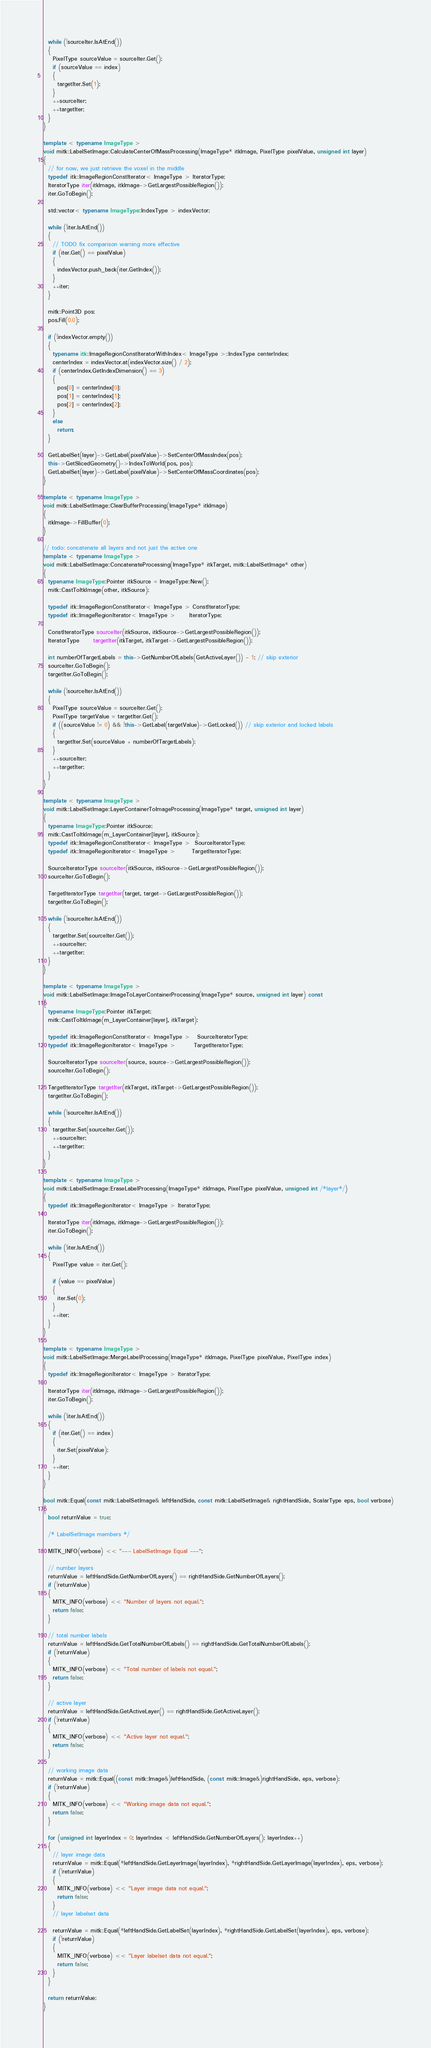<code> <loc_0><loc_0><loc_500><loc_500><_C++_>  while (!sourceIter.IsAtEnd())
  {
    PixelType sourceValue = sourceIter.Get();
    if (sourceValue == index)
    {
      targetIter.Set(1);
    }
    ++sourceIter;
    ++targetIter;
  }
}

template < typename ImageType >
void mitk::LabelSetImage::CalculateCenterOfMassProcessing(ImageType* itkImage, PixelType pixelValue, unsigned int layer)
{
  // for now, we just retrieve the voxel in the middle
  typedef itk::ImageRegionConstIterator< ImageType > IteratorType;
  IteratorType iter(itkImage, itkImage->GetLargestPossibleRegion());
  iter.GoToBegin();

  std::vector< typename ImageType::IndexType > indexVector;

  while (!iter.IsAtEnd())
  {
    // TODO fix comparison warning more effective
    if (iter.Get() == pixelValue)
    {
      indexVector.push_back(iter.GetIndex());
    }
    ++iter;
  }

  mitk::Point3D pos;
  pos.Fill(0.0);

  if (!indexVector.empty())
  {
    typename itk::ImageRegionConstIteratorWithIndex< ImageType >::IndexType centerIndex;
    centerIndex = indexVector.at(indexVector.size() / 2);
    if (centerIndex.GetIndexDimension() == 3)
    {
      pos[0] = centerIndex[0];
      pos[1] = centerIndex[1];
      pos[2] = centerIndex[2];
    }
    else
      return;
  }

  GetLabelSet(layer)->GetLabel(pixelValue)->SetCenterOfMassIndex(pos);
  this->GetSlicedGeometry()->IndexToWorld(pos, pos);
  GetLabelSet(layer)->GetLabel(pixelValue)->SetCenterOfMassCoordinates(pos);
}

template < typename ImageType >
void mitk::LabelSetImage::ClearBufferProcessing(ImageType* itkImage)
{
  itkImage->FillBuffer(0);
}

// todo: concatenate all layers and not just the active one
template < typename ImageType >
void mitk::LabelSetImage::ConcatenateProcessing(ImageType* itkTarget, mitk::LabelSetImage* other)
{
  typename ImageType::Pointer itkSource = ImageType::New();
  mitk::CastToItkImage(other, itkSource);

  typedef itk::ImageRegionConstIterator< ImageType > ConstIteratorType;
  typedef itk::ImageRegionIterator< ImageType >      IteratorType;

  ConstIteratorType sourceIter(itkSource, itkSource->GetLargestPossibleRegion());
  IteratorType      targetIter(itkTarget, itkTarget->GetLargestPossibleRegion());

  int numberOfTargetLabels = this->GetNumberOfLabels(GetActiveLayer()) - 1; // skip exterior
  sourceIter.GoToBegin();
  targetIter.GoToBegin();

  while (!sourceIter.IsAtEnd())
  {
    PixelType sourceValue = sourceIter.Get();
    PixelType targetValue = targetIter.Get();
    if ((sourceValue != 0) && !this->GetLabel(targetValue)->GetLocked()) // skip exterior and locked labels
    {
      targetIter.Set(sourceValue + numberOfTargetLabels);
    }
    ++sourceIter;
    ++targetIter;
  }
}

template < typename ImageType >
void mitk::LabelSetImage::LayerContainerToImageProcessing(ImageType* target, unsigned int layer)
{
  typename ImageType::Pointer itkSource;
  mitk::CastToItkImage(m_LayerContainer[layer], itkSource);
  typedef itk::ImageRegionConstIterator< ImageType >  SourceIteratorType;
  typedef itk::ImageRegionIterator< ImageType >       TargetIteratorType;

  SourceIteratorType sourceIter(itkSource, itkSource->GetLargestPossibleRegion());
  sourceIter.GoToBegin();

  TargetIteratorType targetIter(target, target->GetLargestPossibleRegion());
  targetIter.GoToBegin();

  while (!sourceIter.IsAtEnd())
  {
    targetIter.Set(sourceIter.Get());
    ++sourceIter;
    ++targetIter;
  }
}

template < typename ImageType >
void mitk::LabelSetImage::ImageToLayerContainerProcessing(ImageType* source, unsigned int layer) const
{
  typename ImageType::Pointer itkTarget;
  mitk::CastToItkImage(m_LayerContainer[layer], itkTarget);

  typedef itk::ImageRegionConstIterator< ImageType >   SourceIteratorType;
  typedef itk::ImageRegionIterator< ImageType >        TargetIteratorType;

  SourceIteratorType sourceIter(source, source->GetLargestPossibleRegion());
  sourceIter.GoToBegin();

  TargetIteratorType targetIter(itkTarget, itkTarget->GetLargestPossibleRegion());
  targetIter.GoToBegin();

  while (!sourceIter.IsAtEnd())
  {
    targetIter.Set(sourceIter.Get());
    ++sourceIter;
    ++targetIter;
  }
}

template < typename ImageType >
void mitk::LabelSetImage::EraseLabelProcessing(ImageType* itkImage, PixelType pixelValue, unsigned int /*layer*/)
{
  typedef itk::ImageRegionIterator< ImageType > IteratorType;

  IteratorType iter(itkImage, itkImage->GetLargestPossibleRegion());
  iter.GoToBegin();

  while (!iter.IsAtEnd())
  {
    PixelType value = iter.Get();

    if (value == pixelValue)
    {
      iter.Set(0);
    }
    ++iter;
  }
}

template < typename ImageType >
void mitk::LabelSetImage::MergeLabelProcessing(ImageType* itkImage, PixelType pixelValue, PixelType index)
{
  typedef itk::ImageRegionIterator< ImageType > IteratorType;

  IteratorType iter(itkImage, itkImage->GetLargestPossibleRegion());
  iter.GoToBegin();

  while (!iter.IsAtEnd())
  {
    if (iter.Get() == index)
    {
      iter.Set(pixelValue);
    }
    ++iter;
  }
}

bool mitk::Equal(const mitk::LabelSetImage& leftHandSide, const mitk::LabelSetImage& rightHandSide, ScalarType eps, bool verbose)
{
  bool returnValue = true;

  /* LabelSetImage members */

  MITK_INFO(verbose) << "--- LabelSetImage Equal ---";

  // number layers
  returnValue = leftHandSide.GetNumberOfLayers() == rightHandSide.GetNumberOfLayers();
  if (!returnValue)
  {
    MITK_INFO(verbose) << "Number of layers not equal.";
    return false;
  }

  // total number labels
  returnValue = leftHandSide.GetTotalNumberOfLabels() == rightHandSide.GetTotalNumberOfLabels();
  if (!returnValue)
  {
    MITK_INFO(verbose) << "Total number of labels not equal.";
    return false;
  }

  // active layer
  returnValue = leftHandSide.GetActiveLayer() == rightHandSide.GetActiveLayer();
  if (!returnValue)
  {
    MITK_INFO(verbose) << "Active layer not equal.";
    return false;
  }

  // working image data
  returnValue = mitk::Equal((const mitk::Image&)leftHandSide, (const mitk::Image&)rightHandSide, eps, verbose);
  if (!returnValue)
  {
    MITK_INFO(verbose) << "Working image data not equal.";
    return false;
  }

  for (unsigned int layerIndex = 0; layerIndex < leftHandSide.GetNumberOfLayers(); layerIndex++)
  {
    // layer image data
    returnValue = mitk::Equal(*leftHandSide.GetLayerImage(layerIndex), *rightHandSide.GetLayerImage(layerIndex), eps, verbose);
    if (!returnValue)
    {
      MITK_INFO(verbose) << "Layer image data not equal.";
      return false;
    }
    // layer labelset data

    returnValue = mitk::Equal(*leftHandSide.GetLabelSet(layerIndex), *rightHandSide.GetLabelSet(layerIndex), eps, verbose);
    if (!returnValue)
    {
      MITK_INFO(verbose) << "Layer labelset data not equal.";
      return false;
    }
  }

  return returnValue;
}</code> 